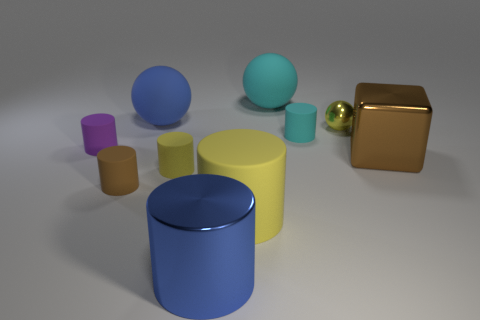Subtract all purple cylinders. How many cylinders are left? 5 Subtract all shiny cylinders. How many cylinders are left? 5 Subtract all green cylinders. Subtract all green spheres. How many cylinders are left? 6 Subtract all cylinders. How many objects are left? 4 Subtract all big yellow cylinders. Subtract all small matte cylinders. How many objects are left? 5 Add 5 big yellow cylinders. How many big yellow cylinders are left? 6 Add 4 large rubber cylinders. How many large rubber cylinders exist? 5 Subtract 0 brown balls. How many objects are left? 10 